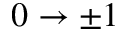<formula> <loc_0><loc_0><loc_500><loc_500>0 \rightarrow \pm 1</formula> 